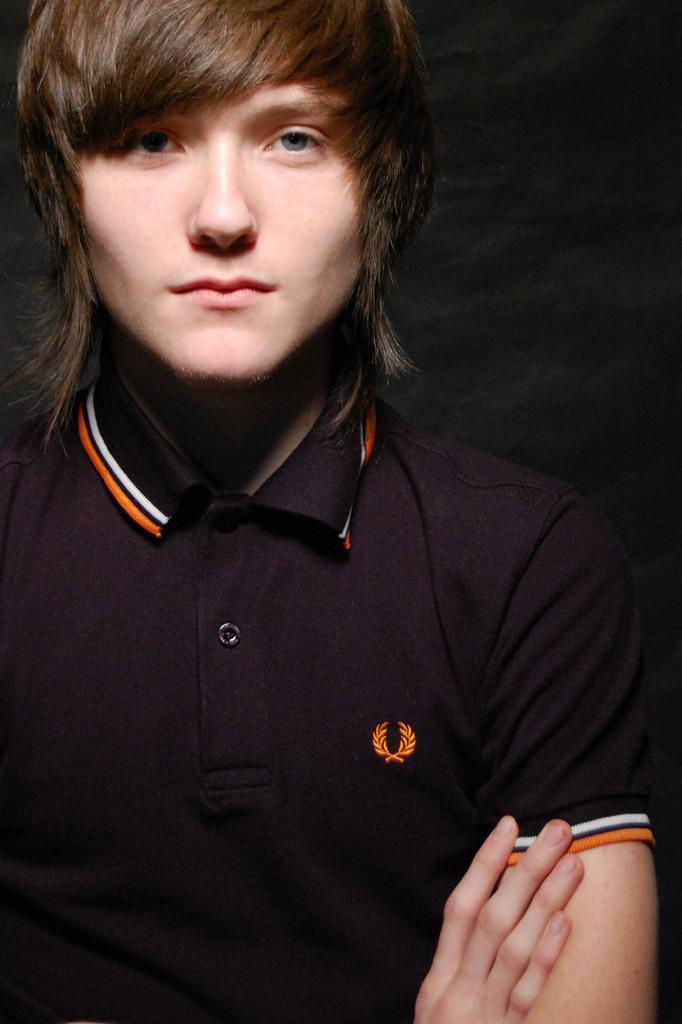Please provide a concise description of this image. A person is standing, this person wore a black color t-shirt. 